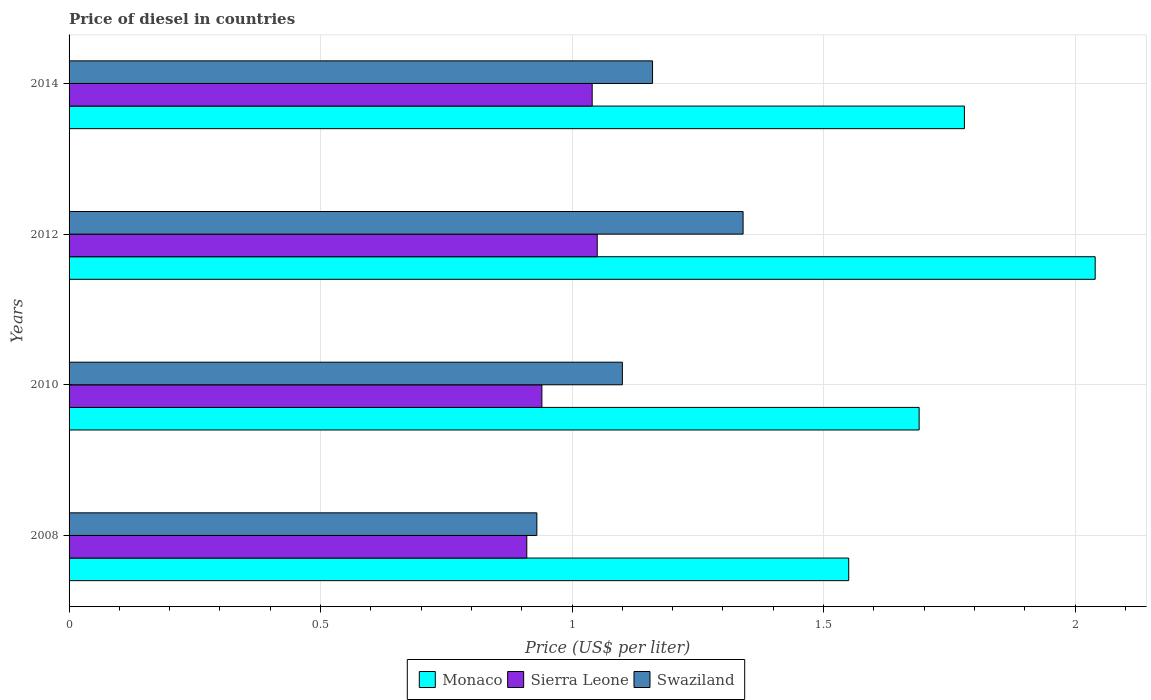How many groups of bars are there?
Your answer should be compact. 4. Are the number of bars on each tick of the Y-axis equal?
Offer a terse response. Yes. How many bars are there on the 4th tick from the bottom?
Give a very brief answer. 3. What is the label of the 1st group of bars from the top?
Offer a terse response. 2014. In how many cases, is the number of bars for a given year not equal to the number of legend labels?
Make the answer very short. 0. What is the price of diesel in Monaco in 2010?
Your response must be concise. 1.69. Across all years, what is the maximum price of diesel in Monaco?
Your answer should be very brief. 2.04. Across all years, what is the minimum price of diesel in Swaziland?
Keep it short and to the point. 0.93. In which year was the price of diesel in Monaco minimum?
Ensure brevity in your answer.  2008. What is the total price of diesel in Monaco in the graph?
Keep it short and to the point. 7.06. What is the difference between the price of diesel in Swaziland in 2010 and that in 2014?
Keep it short and to the point. -0.06. What is the difference between the price of diesel in Swaziland in 2010 and the price of diesel in Monaco in 2008?
Ensure brevity in your answer.  -0.45. What is the average price of diesel in Monaco per year?
Provide a short and direct response. 1.77. In the year 2010, what is the difference between the price of diesel in Monaco and price of diesel in Sierra Leone?
Your answer should be compact. 0.75. What is the ratio of the price of diesel in Swaziland in 2008 to that in 2014?
Offer a terse response. 0.8. Is the difference between the price of diesel in Monaco in 2012 and 2014 greater than the difference between the price of diesel in Sierra Leone in 2012 and 2014?
Offer a very short reply. Yes. What is the difference between the highest and the second highest price of diesel in Sierra Leone?
Keep it short and to the point. 0.01. What is the difference between the highest and the lowest price of diesel in Monaco?
Offer a very short reply. 0.49. What does the 1st bar from the top in 2014 represents?
Your answer should be compact. Swaziland. What does the 1st bar from the bottom in 2014 represents?
Keep it short and to the point. Monaco. How many bars are there?
Make the answer very short. 12. Are all the bars in the graph horizontal?
Offer a very short reply. Yes. What is the difference between two consecutive major ticks on the X-axis?
Your answer should be compact. 0.5. Are the values on the major ticks of X-axis written in scientific E-notation?
Offer a very short reply. No. Does the graph contain any zero values?
Keep it short and to the point. No. Does the graph contain grids?
Your answer should be compact. Yes. Where does the legend appear in the graph?
Your answer should be very brief. Bottom center. How many legend labels are there?
Provide a short and direct response. 3. How are the legend labels stacked?
Your answer should be compact. Horizontal. What is the title of the graph?
Give a very brief answer. Price of diesel in countries. What is the label or title of the X-axis?
Give a very brief answer. Price (US$ per liter). What is the label or title of the Y-axis?
Your answer should be very brief. Years. What is the Price (US$ per liter) of Monaco in 2008?
Give a very brief answer. 1.55. What is the Price (US$ per liter) in Sierra Leone in 2008?
Provide a succinct answer. 0.91. What is the Price (US$ per liter) of Monaco in 2010?
Make the answer very short. 1.69. What is the Price (US$ per liter) of Monaco in 2012?
Your answer should be compact. 2.04. What is the Price (US$ per liter) in Sierra Leone in 2012?
Offer a terse response. 1.05. What is the Price (US$ per liter) of Swaziland in 2012?
Offer a very short reply. 1.34. What is the Price (US$ per liter) of Monaco in 2014?
Your answer should be very brief. 1.78. What is the Price (US$ per liter) in Swaziland in 2014?
Offer a very short reply. 1.16. Across all years, what is the maximum Price (US$ per liter) in Monaco?
Provide a succinct answer. 2.04. Across all years, what is the maximum Price (US$ per liter) in Swaziland?
Your answer should be very brief. 1.34. Across all years, what is the minimum Price (US$ per liter) in Monaco?
Keep it short and to the point. 1.55. Across all years, what is the minimum Price (US$ per liter) of Sierra Leone?
Ensure brevity in your answer.  0.91. Across all years, what is the minimum Price (US$ per liter) in Swaziland?
Provide a short and direct response. 0.93. What is the total Price (US$ per liter) in Monaco in the graph?
Keep it short and to the point. 7.06. What is the total Price (US$ per liter) in Sierra Leone in the graph?
Give a very brief answer. 3.94. What is the total Price (US$ per liter) of Swaziland in the graph?
Offer a terse response. 4.53. What is the difference between the Price (US$ per liter) of Monaco in 2008 and that in 2010?
Offer a terse response. -0.14. What is the difference between the Price (US$ per liter) of Sierra Leone in 2008 and that in 2010?
Make the answer very short. -0.03. What is the difference between the Price (US$ per liter) of Swaziland in 2008 and that in 2010?
Your response must be concise. -0.17. What is the difference between the Price (US$ per liter) in Monaco in 2008 and that in 2012?
Give a very brief answer. -0.49. What is the difference between the Price (US$ per liter) of Sierra Leone in 2008 and that in 2012?
Offer a terse response. -0.14. What is the difference between the Price (US$ per liter) in Swaziland in 2008 and that in 2012?
Keep it short and to the point. -0.41. What is the difference between the Price (US$ per liter) in Monaco in 2008 and that in 2014?
Ensure brevity in your answer.  -0.23. What is the difference between the Price (US$ per liter) of Sierra Leone in 2008 and that in 2014?
Give a very brief answer. -0.13. What is the difference between the Price (US$ per liter) in Swaziland in 2008 and that in 2014?
Keep it short and to the point. -0.23. What is the difference between the Price (US$ per liter) in Monaco in 2010 and that in 2012?
Your answer should be compact. -0.35. What is the difference between the Price (US$ per liter) of Sierra Leone in 2010 and that in 2012?
Keep it short and to the point. -0.11. What is the difference between the Price (US$ per liter) in Swaziland in 2010 and that in 2012?
Your answer should be compact. -0.24. What is the difference between the Price (US$ per liter) of Monaco in 2010 and that in 2014?
Provide a short and direct response. -0.09. What is the difference between the Price (US$ per liter) of Sierra Leone in 2010 and that in 2014?
Offer a very short reply. -0.1. What is the difference between the Price (US$ per liter) of Swaziland in 2010 and that in 2014?
Your answer should be compact. -0.06. What is the difference between the Price (US$ per liter) in Monaco in 2012 and that in 2014?
Your answer should be very brief. 0.26. What is the difference between the Price (US$ per liter) of Sierra Leone in 2012 and that in 2014?
Your response must be concise. 0.01. What is the difference between the Price (US$ per liter) in Swaziland in 2012 and that in 2014?
Your answer should be compact. 0.18. What is the difference between the Price (US$ per liter) in Monaco in 2008 and the Price (US$ per liter) in Sierra Leone in 2010?
Provide a succinct answer. 0.61. What is the difference between the Price (US$ per liter) of Monaco in 2008 and the Price (US$ per liter) of Swaziland in 2010?
Make the answer very short. 0.45. What is the difference between the Price (US$ per liter) in Sierra Leone in 2008 and the Price (US$ per liter) in Swaziland in 2010?
Make the answer very short. -0.19. What is the difference between the Price (US$ per liter) in Monaco in 2008 and the Price (US$ per liter) in Sierra Leone in 2012?
Your answer should be very brief. 0.5. What is the difference between the Price (US$ per liter) of Monaco in 2008 and the Price (US$ per liter) of Swaziland in 2012?
Your answer should be compact. 0.21. What is the difference between the Price (US$ per liter) of Sierra Leone in 2008 and the Price (US$ per liter) of Swaziland in 2012?
Provide a succinct answer. -0.43. What is the difference between the Price (US$ per liter) of Monaco in 2008 and the Price (US$ per liter) of Sierra Leone in 2014?
Offer a terse response. 0.51. What is the difference between the Price (US$ per liter) of Monaco in 2008 and the Price (US$ per liter) of Swaziland in 2014?
Offer a terse response. 0.39. What is the difference between the Price (US$ per liter) of Monaco in 2010 and the Price (US$ per liter) of Sierra Leone in 2012?
Your answer should be very brief. 0.64. What is the difference between the Price (US$ per liter) in Monaco in 2010 and the Price (US$ per liter) in Swaziland in 2012?
Your response must be concise. 0.35. What is the difference between the Price (US$ per liter) of Monaco in 2010 and the Price (US$ per liter) of Sierra Leone in 2014?
Your answer should be very brief. 0.65. What is the difference between the Price (US$ per liter) of Monaco in 2010 and the Price (US$ per liter) of Swaziland in 2014?
Provide a short and direct response. 0.53. What is the difference between the Price (US$ per liter) of Sierra Leone in 2010 and the Price (US$ per liter) of Swaziland in 2014?
Your answer should be compact. -0.22. What is the difference between the Price (US$ per liter) in Monaco in 2012 and the Price (US$ per liter) in Sierra Leone in 2014?
Give a very brief answer. 1. What is the difference between the Price (US$ per liter) of Sierra Leone in 2012 and the Price (US$ per liter) of Swaziland in 2014?
Offer a terse response. -0.11. What is the average Price (US$ per liter) in Monaco per year?
Your response must be concise. 1.76. What is the average Price (US$ per liter) in Sierra Leone per year?
Ensure brevity in your answer.  0.98. What is the average Price (US$ per liter) in Swaziland per year?
Ensure brevity in your answer.  1.13. In the year 2008, what is the difference between the Price (US$ per liter) of Monaco and Price (US$ per liter) of Sierra Leone?
Keep it short and to the point. 0.64. In the year 2008, what is the difference between the Price (US$ per liter) in Monaco and Price (US$ per liter) in Swaziland?
Make the answer very short. 0.62. In the year 2008, what is the difference between the Price (US$ per liter) of Sierra Leone and Price (US$ per liter) of Swaziland?
Offer a terse response. -0.02. In the year 2010, what is the difference between the Price (US$ per liter) in Monaco and Price (US$ per liter) in Swaziland?
Give a very brief answer. 0.59. In the year 2010, what is the difference between the Price (US$ per liter) in Sierra Leone and Price (US$ per liter) in Swaziland?
Offer a very short reply. -0.16. In the year 2012, what is the difference between the Price (US$ per liter) in Monaco and Price (US$ per liter) in Sierra Leone?
Give a very brief answer. 0.99. In the year 2012, what is the difference between the Price (US$ per liter) in Monaco and Price (US$ per liter) in Swaziland?
Keep it short and to the point. 0.7. In the year 2012, what is the difference between the Price (US$ per liter) of Sierra Leone and Price (US$ per liter) of Swaziland?
Provide a succinct answer. -0.29. In the year 2014, what is the difference between the Price (US$ per liter) in Monaco and Price (US$ per liter) in Sierra Leone?
Your answer should be compact. 0.74. In the year 2014, what is the difference between the Price (US$ per liter) in Monaco and Price (US$ per liter) in Swaziland?
Offer a terse response. 0.62. In the year 2014, what is the difference between the Price (US$ per liter) in Sierra Leone and Price (US$ per liter) in Swaziland?
Your response must be concise. -0.12. What is the ratio of the Price (US$ per liter) in Monaco in 2008 to that in 2010?
Offer a terse response. 0.92. What is the ratio of the Price (US$ per liter) in Sierra Leone in 2008 to that in 2010?
Provide a short and direct response. 0.97. What is the ratio of the Price (US$ per liter) in Swaziland in 2008 to that in 2010?
Your response must be concise. 0.85. What is the ratio of the Price (US$ per liter) in Monaco in 2008 to that in 2012?
Your answer should be very brief. 0.76. What is the ratio of the Price (US$ per liter) in Sierra Leone in 2008 to that in 2012?
Your response must be concise. 0.87. What is the ratio of the Price (US$ per liter) in Swaziland in 2008 to that in 2012?
Offer a terse response. 0.69. What is the ratio of the Price (US$ per liter) in Monaco in 2008 to that in 2014?
Your answer should be compact. 0.87. What is the ratio of the Price (US$ per liter) of Sierra Leone in 2008 to that in 2014?
Make the answer very short. 0.88. What is the ratio of the Price (US$ per liter) in Swaziland in 2008 to that in 2014?
Your response must be concise. 0.8. What is the ratio of the Price (US$ per liter) of Monaco in 2010 to that in 2012?
Give a very brief answer. 0.83. What is the ratio of the Price (US$ per liter) in Sierra Leone in 2010 to that in 2012?
Your response must be concise. 0.9. What is the ratio of the Price (US$ per liter) in Swaziland in 2010 to that in 2012?
Your response must be concise. 0.82. What is the ratio of the Price (US$ per liter) in Monaco in 2010 to that in 2014?
Keep it short and to the point. 0.95. What is the ratio of the Price (US$ per liter) in Sierra Leone in 2010 to that in 2014?
Ensure brevity in your answer.  0.9. What is the ratio of the Price (US$ per liter) of Swaziland in 2010 to that in 2014?
Ensure brevity in your answer.  0.95. What is the ratio of the Price (US$ per liter) of Monaco in 2012 to that in 2014?
Make the answer very short. 1.15. What is the ratio of the Price (US$ per liter) of Sierra Leone in 2012 to that in 2014?
Give a very brief answer. 1.01. What is the ratio of the Price (US$ per liter) of Swaziland in 2012 to that in 2014?
Keep it short and to the point. 1.16. What is the difference between the highest and the second highest Price (US$ per liter) of Monaco?
Offer a terse response. 0.26. What is the difference between the highest and the second highest Price (US$ per liter) in Sierra Leone?
Provide a succinct answer. 0.01. What is the difference between the highest and the second highest Price (US$ per liter) in Swaziland?
Make the answer very short. 0.18. What is the difference between the highest and the lowest Price (US$ per liter) in Monaco?
Give a very brief answer. 0.49. What is the difference between the highest and the lowest Price (US$ per liter) in Sierra Leone?
Keep it short and to the point. 0.14. What is the difference between the highest and the lowest Price (US$ per liter) in Swaziland?
Ensure brevity in your answer.  0.41. 